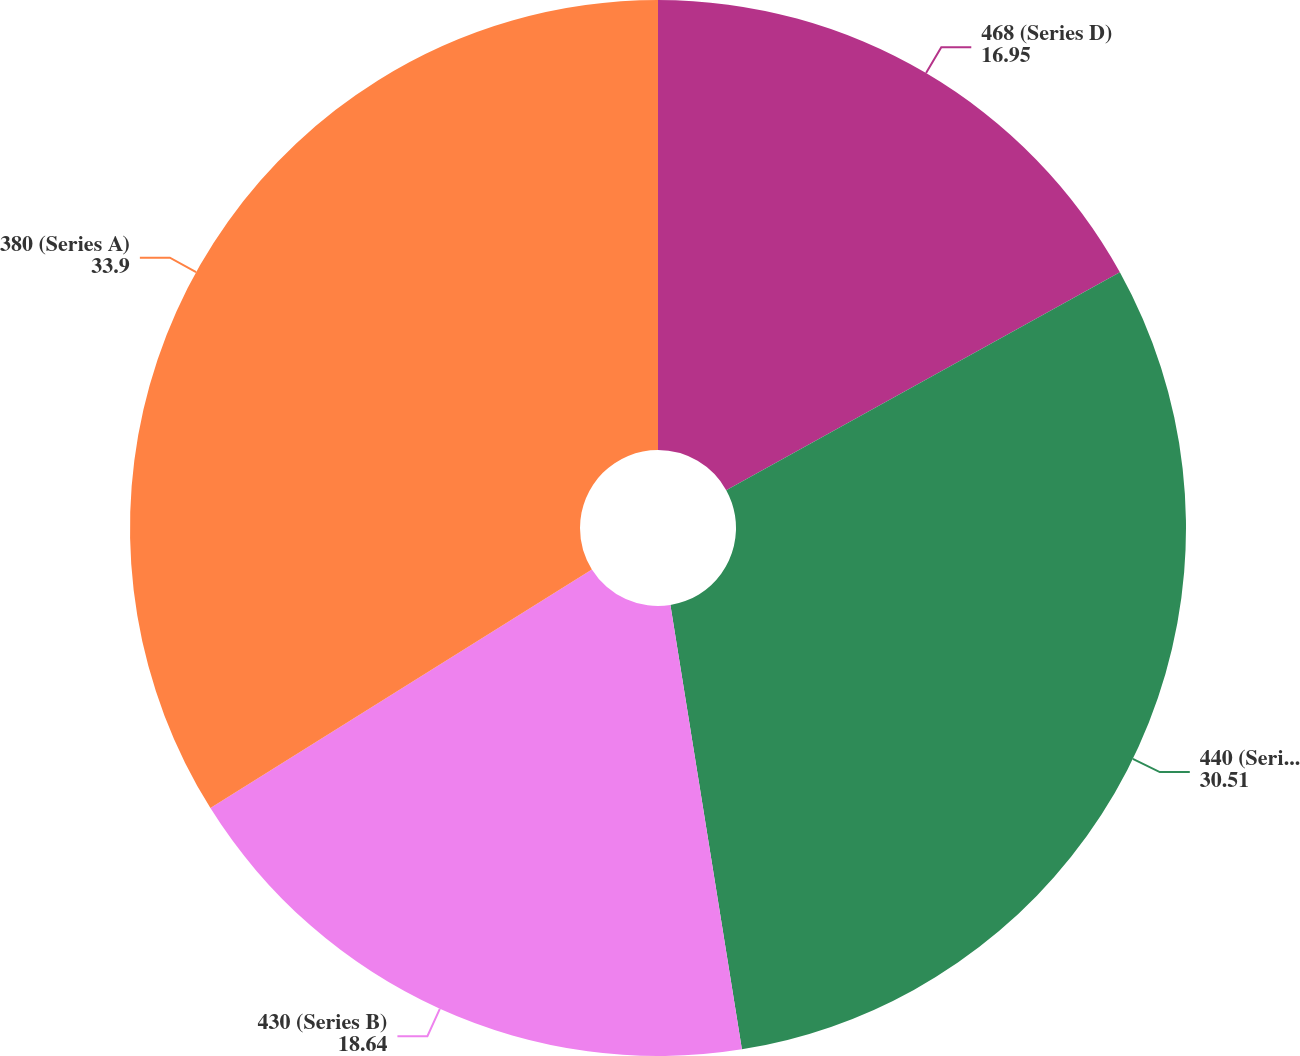Convert chart. <chart><loc_0><loc_0><loc_500><loc_500><pie_chart><fcel>468 (Series D)<fcel>440 (Series C)<fcel>430 (Series B)<fcel>380 (Series A)<nl><fcel>16.95%<fcel>30.51%<fcel>18.64%<fcel>33.9%<nl></chart> 